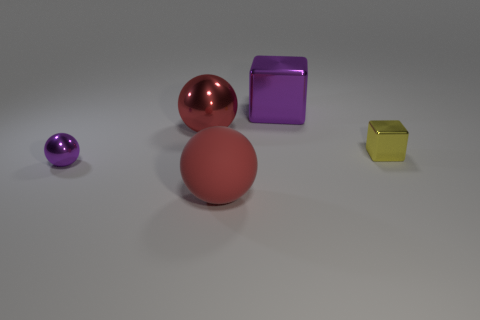How does the lighting in the image affect the appearance of the objects? The lighting in the image is diffuse and appears to be coming from above. This soft lighting minimizes harsh shadows and allows the inherent colors and textures of the objects to be more distinct. The reflective surface of the large red shiny sphere in particular catches the light, creating highlights that enhance its glossy finish, in contrast to the matte texture of the other red ball and the translucent quality of the small yellow cube. 